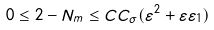Convert formula to latex. <formula><loc_0><loc_0><loc_500><loc_500>0 \leq 2 - N _ { m } \leq C C _ { \sigma } ( \varepsilon ^ { 2 } + \varepsilon \varepsilon _ { 1 } )</formula> 